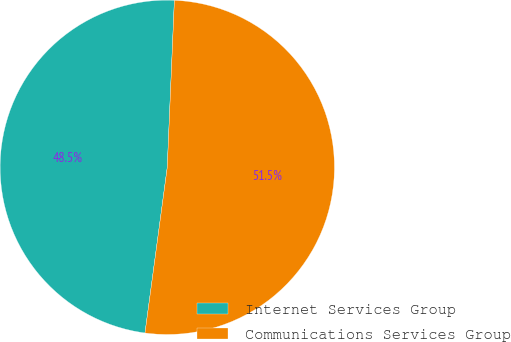<chart> <loc_0><loc_0><loc_500><loc_500><pie_chart><fcel>Internet Services Group<fcel>Communications Services Group<nl><fcel>48.55%<fcel>51.45%<nl></chart> 